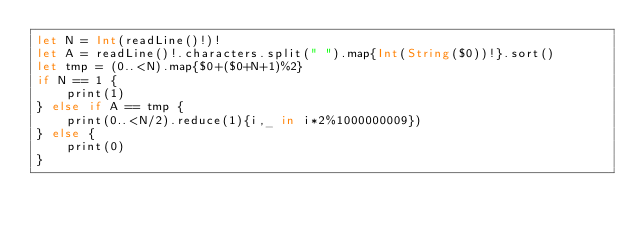Convert code to text. <code><loc_0><loc_0><loc_500><loc_500><_Swift_>let N = Int(readLine()!)!
let A = readLine()!.characters.split(" ").map{Int(String($0))!}.sort()
let tmp = (0..<N).map{$0+($0+N+1)%2}
if N == 1 {
    print(1)
} else if A == tmp {
    print(0..<N/2).reduce(1){i,_ in i*2%1000000009})
} else {
    print(0)
}</code> 